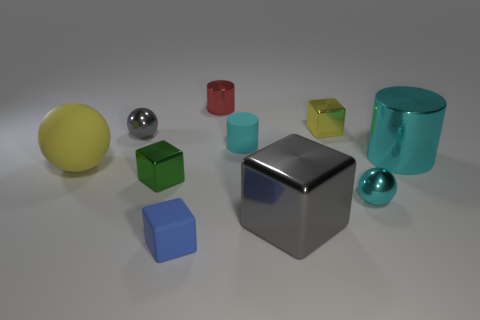Subtract all yellow metallic blocks. How many blocks are left? 3 Subtract 2 blocks. How many blocks are left? 2 Subtract all blue cubes. How many cubes are left? 3 Subtract all red cubes. Subtract all gray cylinders. How many cubes are left? 4 Subtract all cubes. How many objects are left? 6 Add 6 yellow shiny cubes. How many yellow shiny cubes exist? 7 Subtract 0 brown blocks. How many objects are left? 10 Subtract all tiny purple spheres. Subtract all red cylinders. How many objects are left? 9 Add 6 cyan things. How many cyan things are left? 9 